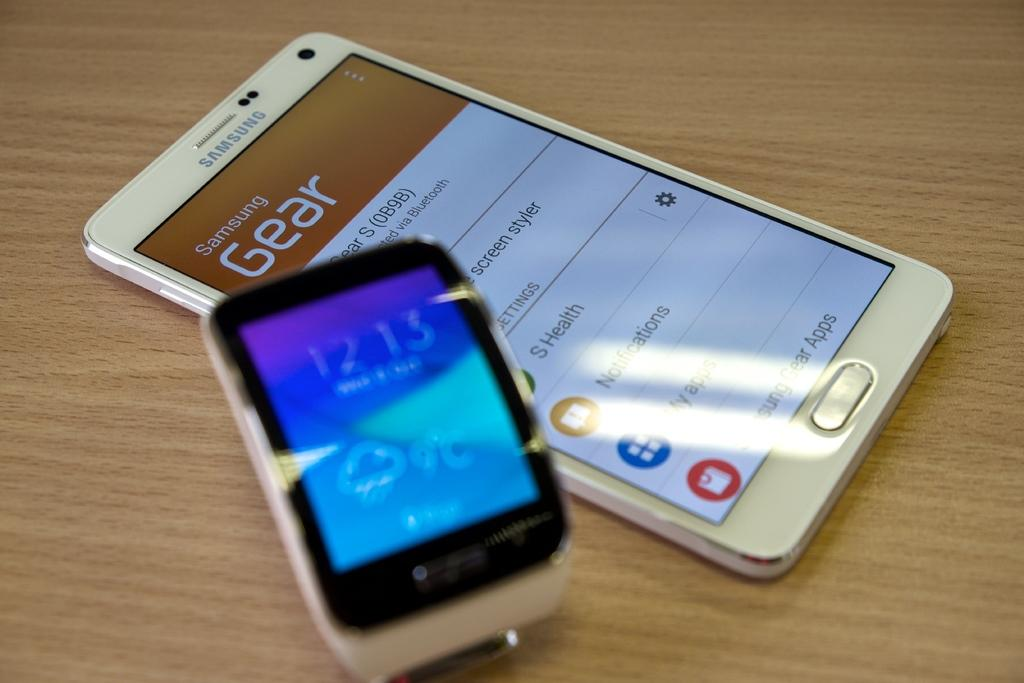Provide a one-sentence caption for the provided image. A Samsung Gear cellphone laying on a table next to another electronic device showing the time. 